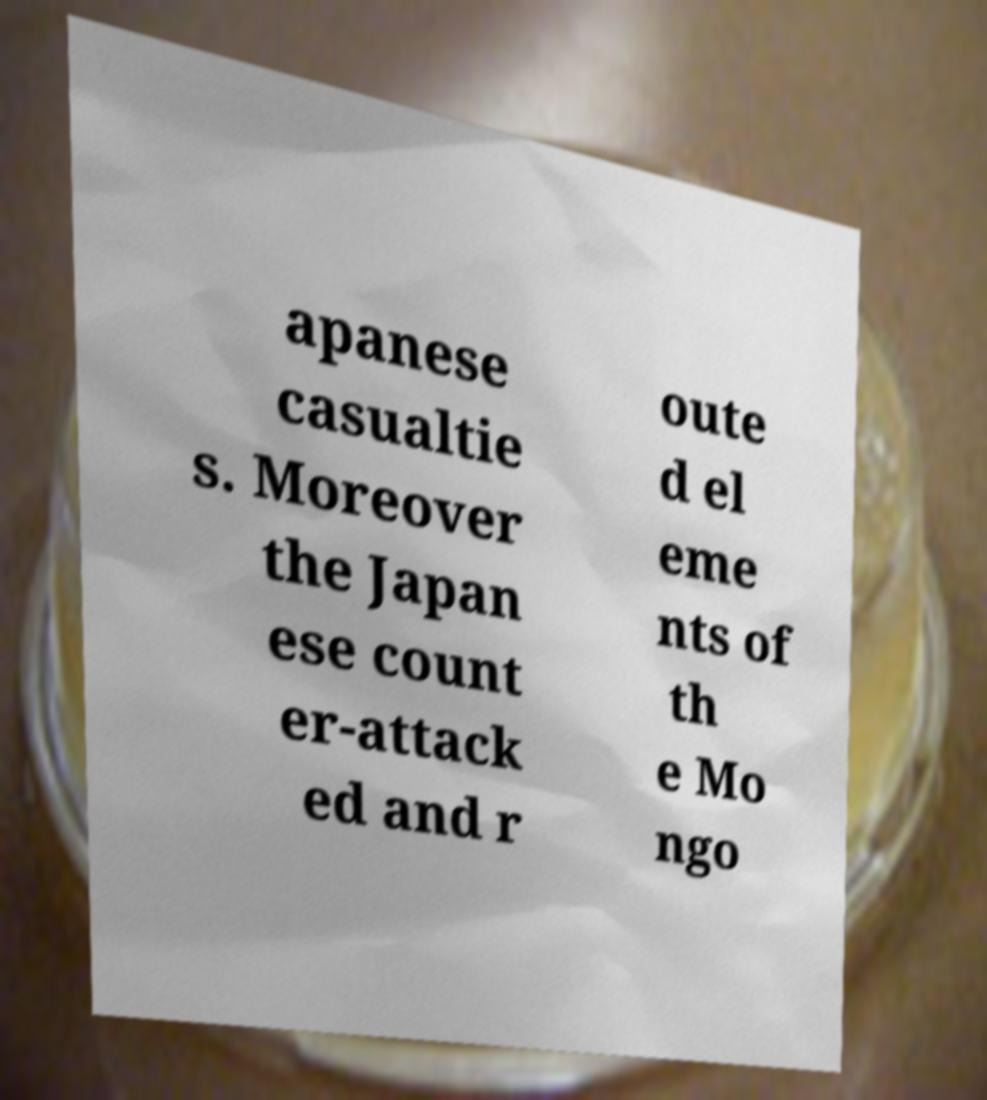Could you extract and type out the text from this image? apanese casualtie s. Moreover the Japan ese count er-attack ed and r oute d el eme nts of th e Mo ngo 